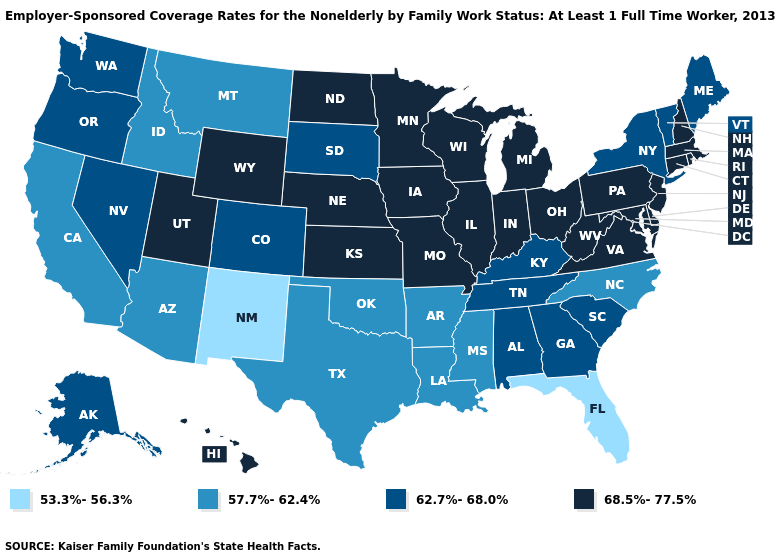Name the states that have a value in the range 68.5%-77.5%?
Be succinct. Connecticut, Delaware, Hawaii, Illinois, Indiana, Iowa, Kansas, Maryland, Massachusetts, Michigan, Minnesota, Missouri, Nebraska, New Hampshire, New Jersey, North Dakota, Ohio, Pennsylvania, Rhode Island, Utah, Virginia, West Virginia, Wisconsin, Wyoming. What is the value of Wisconsin?
Be succinct. 68.5%-77.5%. Does the map have missing data?
Keep it brief. No. Among the states that border Maryland , which have the highest value?
Concise answer only. Delaware, Pennsylvania, Virginia, West Virginia. Name the states that have a value in the range 68.5%-77.5%?
Give a very brief answer. Connecticut, Delaware, Hawaii, Illinois, Indiana, Iowa, Kansas, Maryland, Massachusetts, Michigan, Minnesota, Missouri, Nebraska, New Hampshire, New Jersey, North Dakota, Ohio, Pennsylvania, Rhode Island, Utah, Virginia, West Virginia, Wisconsin, Wyoming. Name the states that have a value in the range 57.7%-62.4%?
Quick response, please. Arizona, Arkansas, California, Idaho, Louisiana, Mississippi, Montana, North Carolina, Oklahoma, Texas. Is the legend a continuous bar?
Keep it brief. No. Does West Virginia have a higher value than Maryland?
Give a very brief answer. No. Among the states that border California , which have the lowest value?
Keep it brief. Arizona. Does West Virginia have the lowest value in the South?
Be succinct. No. Does Connecticut have the highest value in the USA?
Answer briefly. Yes. Which states have the highest value in the USA?
Give a very brief answer. Connecticut, Delaware, Hawaii, Illinois, Indiana, Iowa, Kansas, Maryland, Massachusetts, Michigan, Minnesota, Missouri, Nebraska, New Hampshire, New Jersey, North Dakota, Ohio, Pennsylvania, Rhode Island, Utah, Virginia, West Virginia, Wisconsin, Wyoming. What is the value of South Dakota?
Concise answer only. 62.7%-68.0%. Among the states that border New Hampshire , which have the lowest value?
Quick response, please. Maine, Vermont. Does Vermont have a higher value than Utah?
Keep it brief. No. 